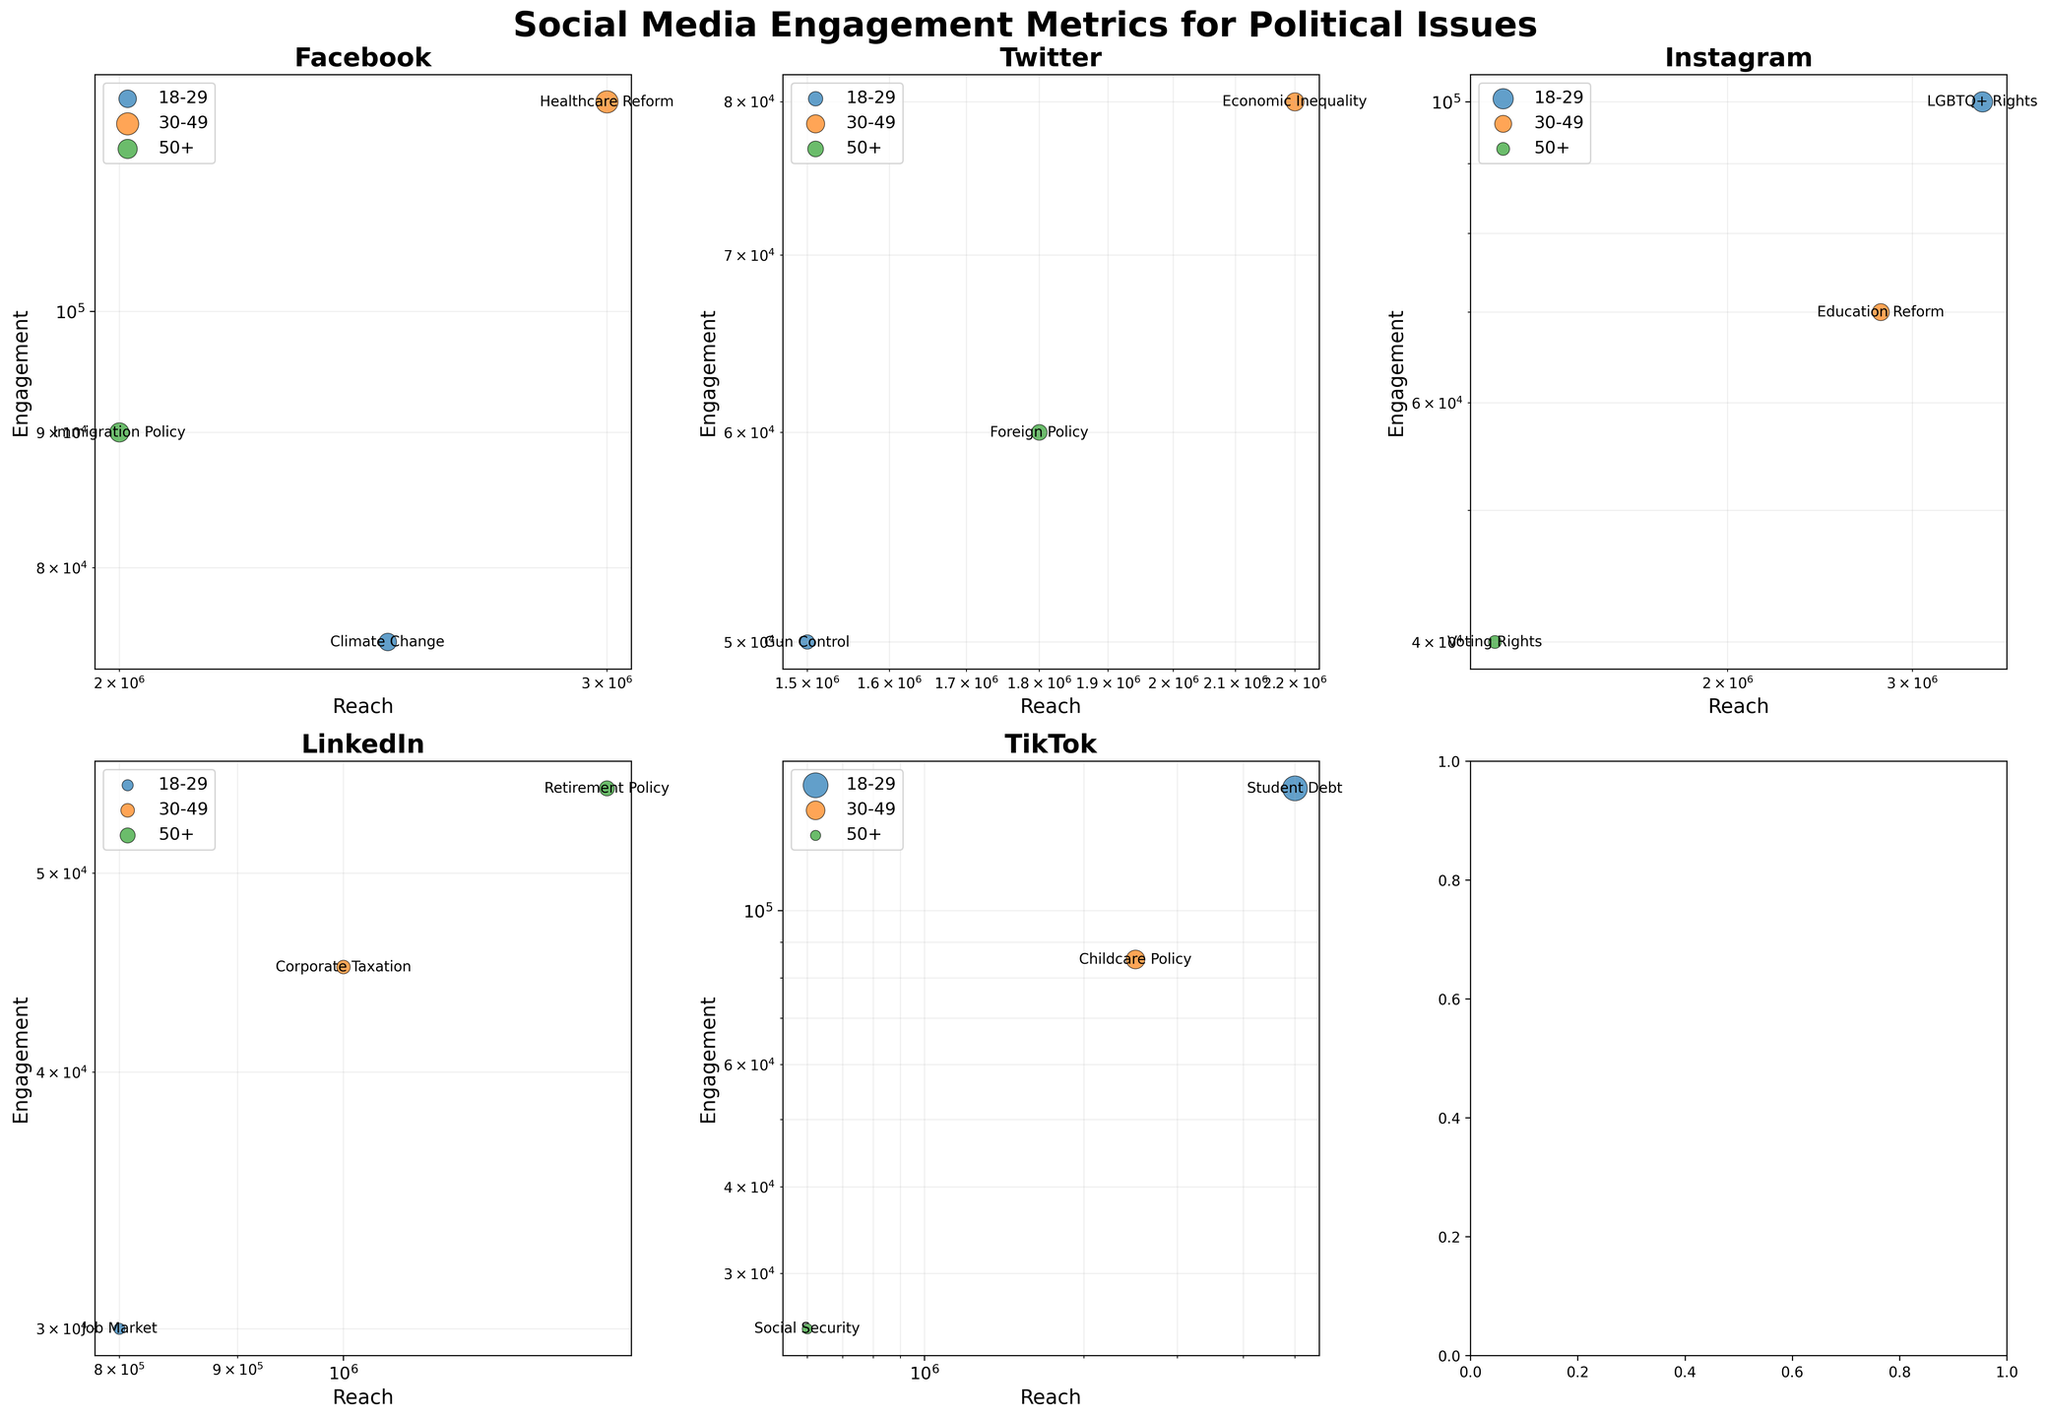What political issue has the highest engagement on Facebook for the age group 30-49? The bubble for the age group 30-49 on the Facebook plot is labeled "Healthcare Reform" and has the highest vertical position, indicating the highest engagement.
Answer: Healthcare Reform Which platform has the most diverse age groups engaging with political issues? Assess the number of age groups represented in each subplot. Platforms like Facebook, Twitter, Instagram, LinkedIn, and TikTok each have three distinct age groups shown on the plot. Therefore, all five mentioned platforms have the most diverse age groups.
Answer: Facebook, Twitter, Instagram, LinkedIn, TikTok What is the reach of the Immigration Policy issue on Facebook for the age group 50+? Locate the "Immigration Policy" bubble for the 50+ age group on the Facebook subplot. Its horizontal position represents reach.
Answer: 2000000 Which age group has the highest engagement on TikTok? In the TikTok subplot, the 18-29 age group bubble, labeled "Student Debt," is the highest vertically, indicating the highest engagement.
Answer: 18-29 Compare the engagement of Climate Change on Facebook to Foreign Policy on Twitter. Which one has higher engagement? The "Climate Change" bubble on Facebook for the 18-29 age group is higher than the "Foreign Policy" bubble on Twitter for the 50+ age group, indicating higher engagement.
Answer: Climate Change For the "Economic Inequality" issue on Twitter, what is the engagement and reach, and what is the bubble size? Locate the "Economic Inequality" bubble for the 30-49 age group on Twitter. The vertical position (engagement) is 80000, horizontal position (reach) is 2200000, and bubble size (proportional to engagement) is 80000 / 500 = 160 units in size.
Answer: Engagement: 80000, Reach: 2200000, Size: 160 Which issue on LinkedIn for the age group 50+ has the highest reach, and what is the value? On LinkedIn, the "Retirement Policy" bubble for the 50+ age group is the furthest right, indicating the highest reach value.
Answer: Retirement Policy, 1300000 Which platform has the smallest engagement bubble size across all issues and age groups? Identify the smallest bubbles by size across all subplots. On TikTok, the "Social Security" issue for the 50+ age group has the smallest bubble size.
Answer: TikTok For the 30-49 age group, what issue on Instagram has the lowest engagement? In the Instagram subplot, locate the issue for the 30-49 age group that is positioned lowest vertically. The "Education Reform" bubble represents this.
Answer: Education Reform Among all platforms and age groups, which issue has the highest reach? Scan all subplots for the bubble furthest to the right, representing the highest reach. "Student Debt" on TikTok for the 18-29 age group is the furthest right.
Answer: Student Debt 